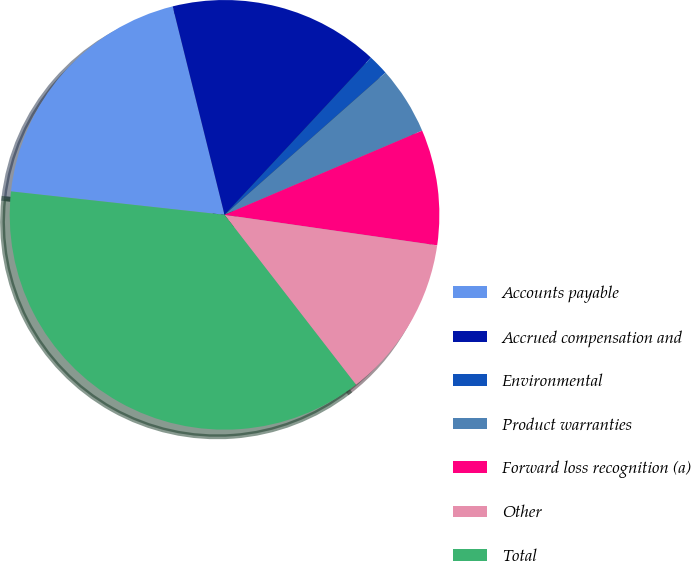Convert chart. <chart><loc_0><loc_0><loc_500><loc_500><pie_chart><fcel>Accounts payable<fcel>Accrued compensation and<fcel>Environmental<fcel>Product warranties<fcel>Forward loss recognition (a)<fcel>Other<fcel>Total<nl><fcel>19.38%<fcel>15.81%<fcel>1.55%<fcel>5.11%<fcel>8.68%<fcel>12.25%<fcel>37.22%<nl></chart> 